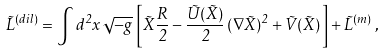<formula> <loc_0><loc_0><loc_500><loc_500>\tilde { L } ^ { ( d i l ) } = \int d ^ { 2 } x \, \sqrt { - g } \, \left [ \tilde { X } \frac { R } { 2 } - \frac { \tilde { U } ( \tilde { X } ) } { 2 } \, ( \nabla \tilde { X } ) ^ { 2 } + \tilde { V } ( \tilde { X } ) \, \right ] + \tilde { L } ^ { ( m ) } \, ,</formula> 